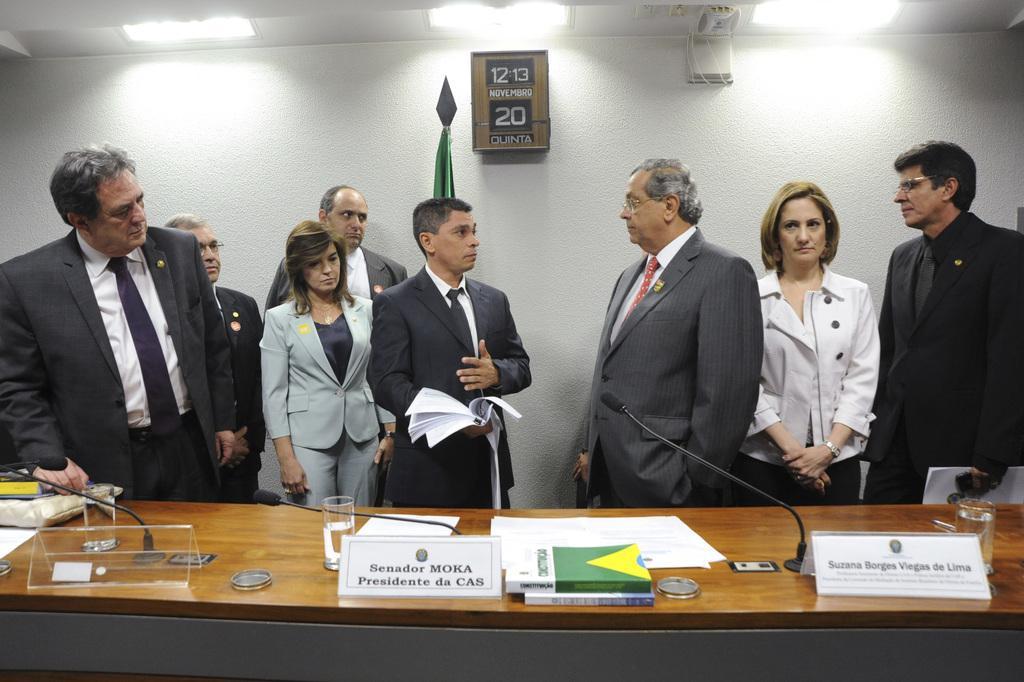Could you give a brief overview of what you see in this image? In this image we can see a few people standing and in front of them there is a table with objects like microphones, books, papers, glasses and some other objects. In the background, we can see the clock attached to the wall and at the top we can see the lights attached to the ceiling. 